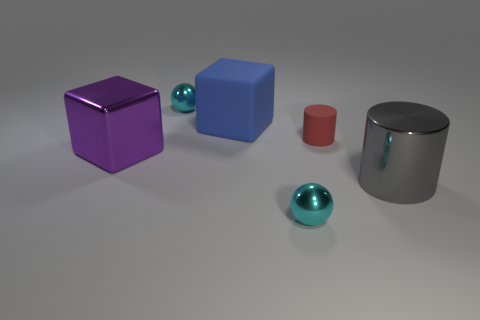There is a object that is to the right of the tiny red rubber cylinder; does it have the same shape as the red matte thing?
Give a very brief answer. Yes. There is a matte object that is the same shape as the gray metallic thing; what color is it?
Ensure brevity in your answer.  Red. There is a blue thing that is the same shape as the purple metallic thing; what is its size?
Offer a very short reply. Large. How many red cylinders are the same material as the blue cube?
Make the answer very short. 1. Are there fewer tiny cyan things in front of the red rubber thing than tiny cyan spheres?
Offer a terse response. Yes. How many green shiny objects are there?
Provide a succinct answer. 0. Do the large purple thing and the large rubber object have the same shape?
Provide a short and direct response. Yes. There is a purple shiny object behind the small cyan sphere that is in front of the small rubber cylinder; what is its size?
Give a very brief answer. Large. Is there a cyan object of the same size as the rubber cylinder?
Offer a very short reply. Yes. Is the size of the purple metallic object that is in front of the tiny matte thing the same as the cylinder on the right side of the small red matte object?
Give a very brief answer. Yes. 